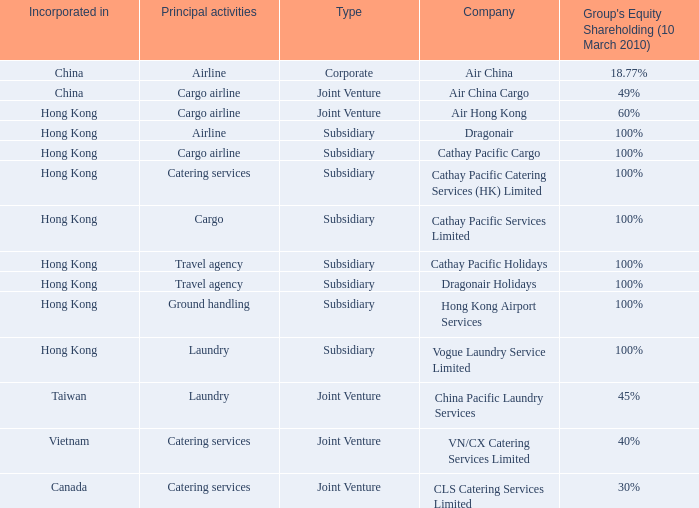Which company has a group equity shareholding percentage, as of March 10th 2010 of 30%? CLS Catering Services Limited. 